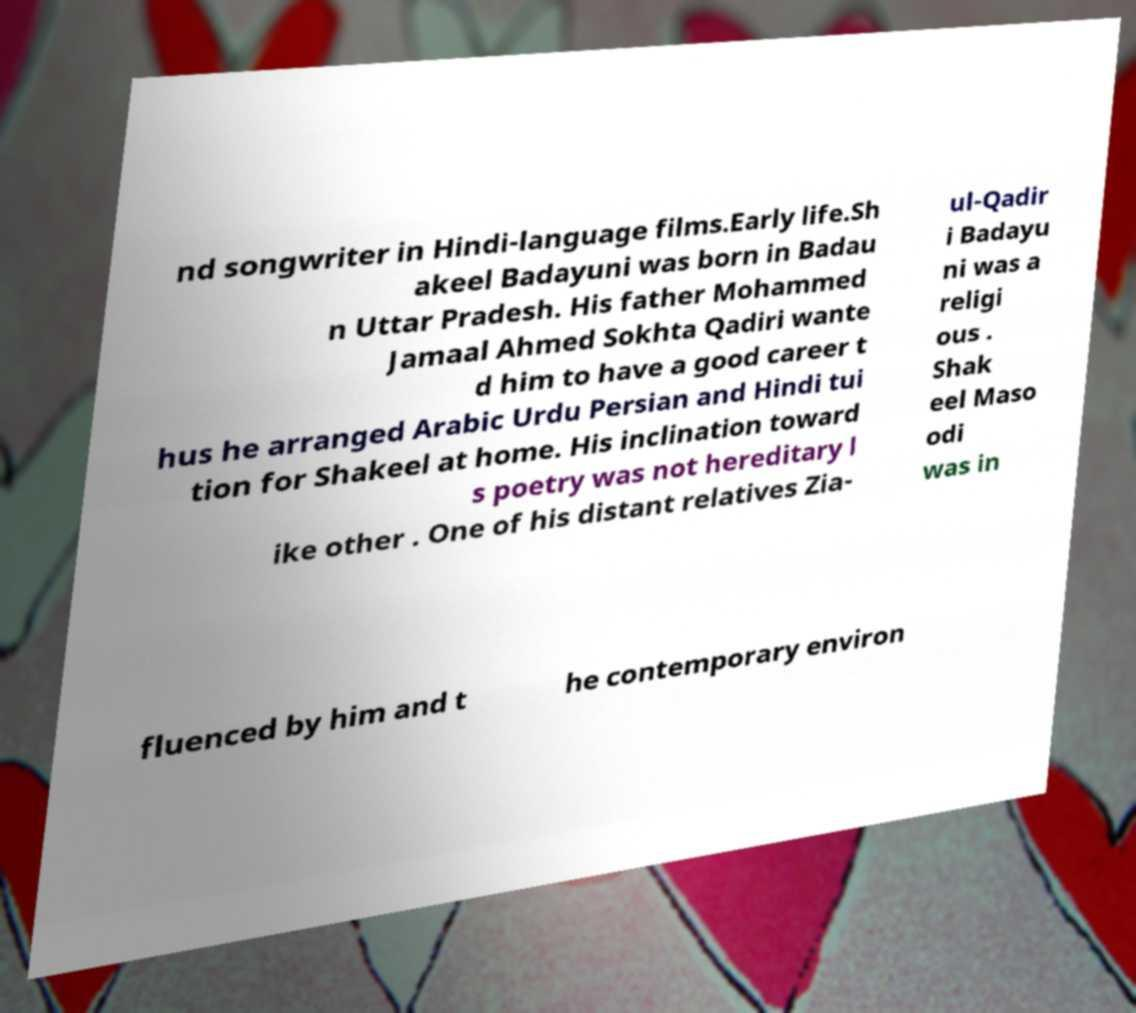What messages or text are displayed in this image? I need them in a readable, typed format. nd songwriter in Hindi-language films.Early life.Sh akeel Badayuni was born in Badau n Uttar Pradesh. His father Mohammed Jamaal Ahmed Sokhta Qadiri wante d him to have a good career t hus he arranged Arabic Urdu Persian and Hindi tui tion for Shakeel at home. His inclination toward s poetry was not hereditary l ike other . One of his distant relatives Zia- ul-Qadir i Badayu ni was a religi ous . Shak eel Maso odi was in fluenced by him and t he contemporary environ 